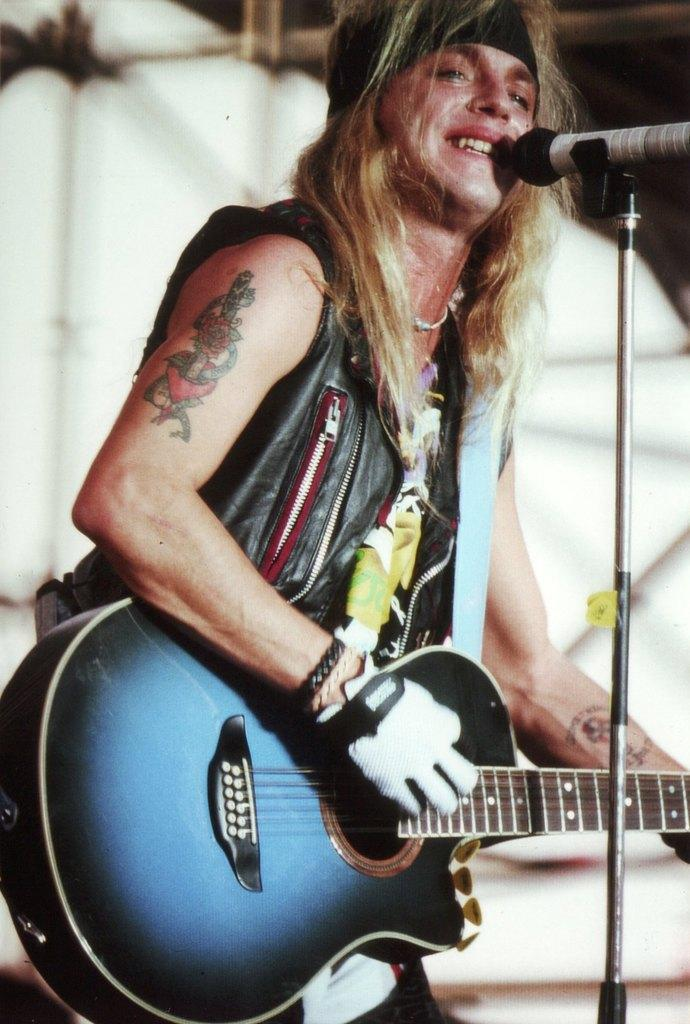What is the main subject of the image? There is a person in the image. What is the person doing in the image? The person is standing and playing a guitar. What object is the person standing in front of? The person is in front of a microphone. What type of goldfish can be seen swimming in the background of the image? There are no goldfish present in the image; it features a person standing in front of a microphone while playing a guitar. 